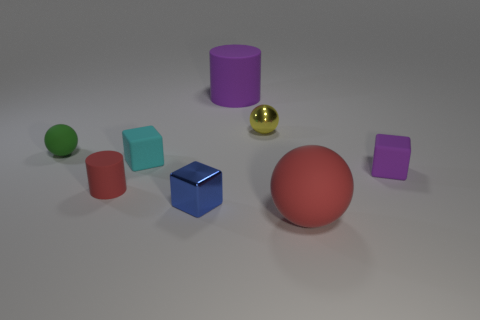The cyan matte object is what shape?
Your answer should be very brief. Cube. There is a tiny purple rubber cube; are there any large rubber cylinders behind it?
Offer a very short reply. Yes. Do the blue block and the red thing that is left of the big purple rubber cylinder have the same material?
Make the answer very short. No. Do the large rubber thing that is in front of the purple rubber block and the small red rubber thing have the same shape?
Offer a very short reply. No. How many small blue cubes are made of the same material as the yellow object?
Provide a succinct answer. 1. How many objects are matte cylinders to the left of the large purple thing or big green metal things?
Your response must be concise. 1. How big is the blue block?
Make the answer very short. Small. The red object on the left side of the matte cylinder behind the tiny green rubber sphere is made of what material?
Your response must be concise. Rubber. There is a cube that is behind the purple rubber block; does it have the same size as the small yellow object?
Keep it short and to the point. Yes. Is there another rubber sphere that has the same color as the tiny matte sphere?
Your answer should be compact. No. 